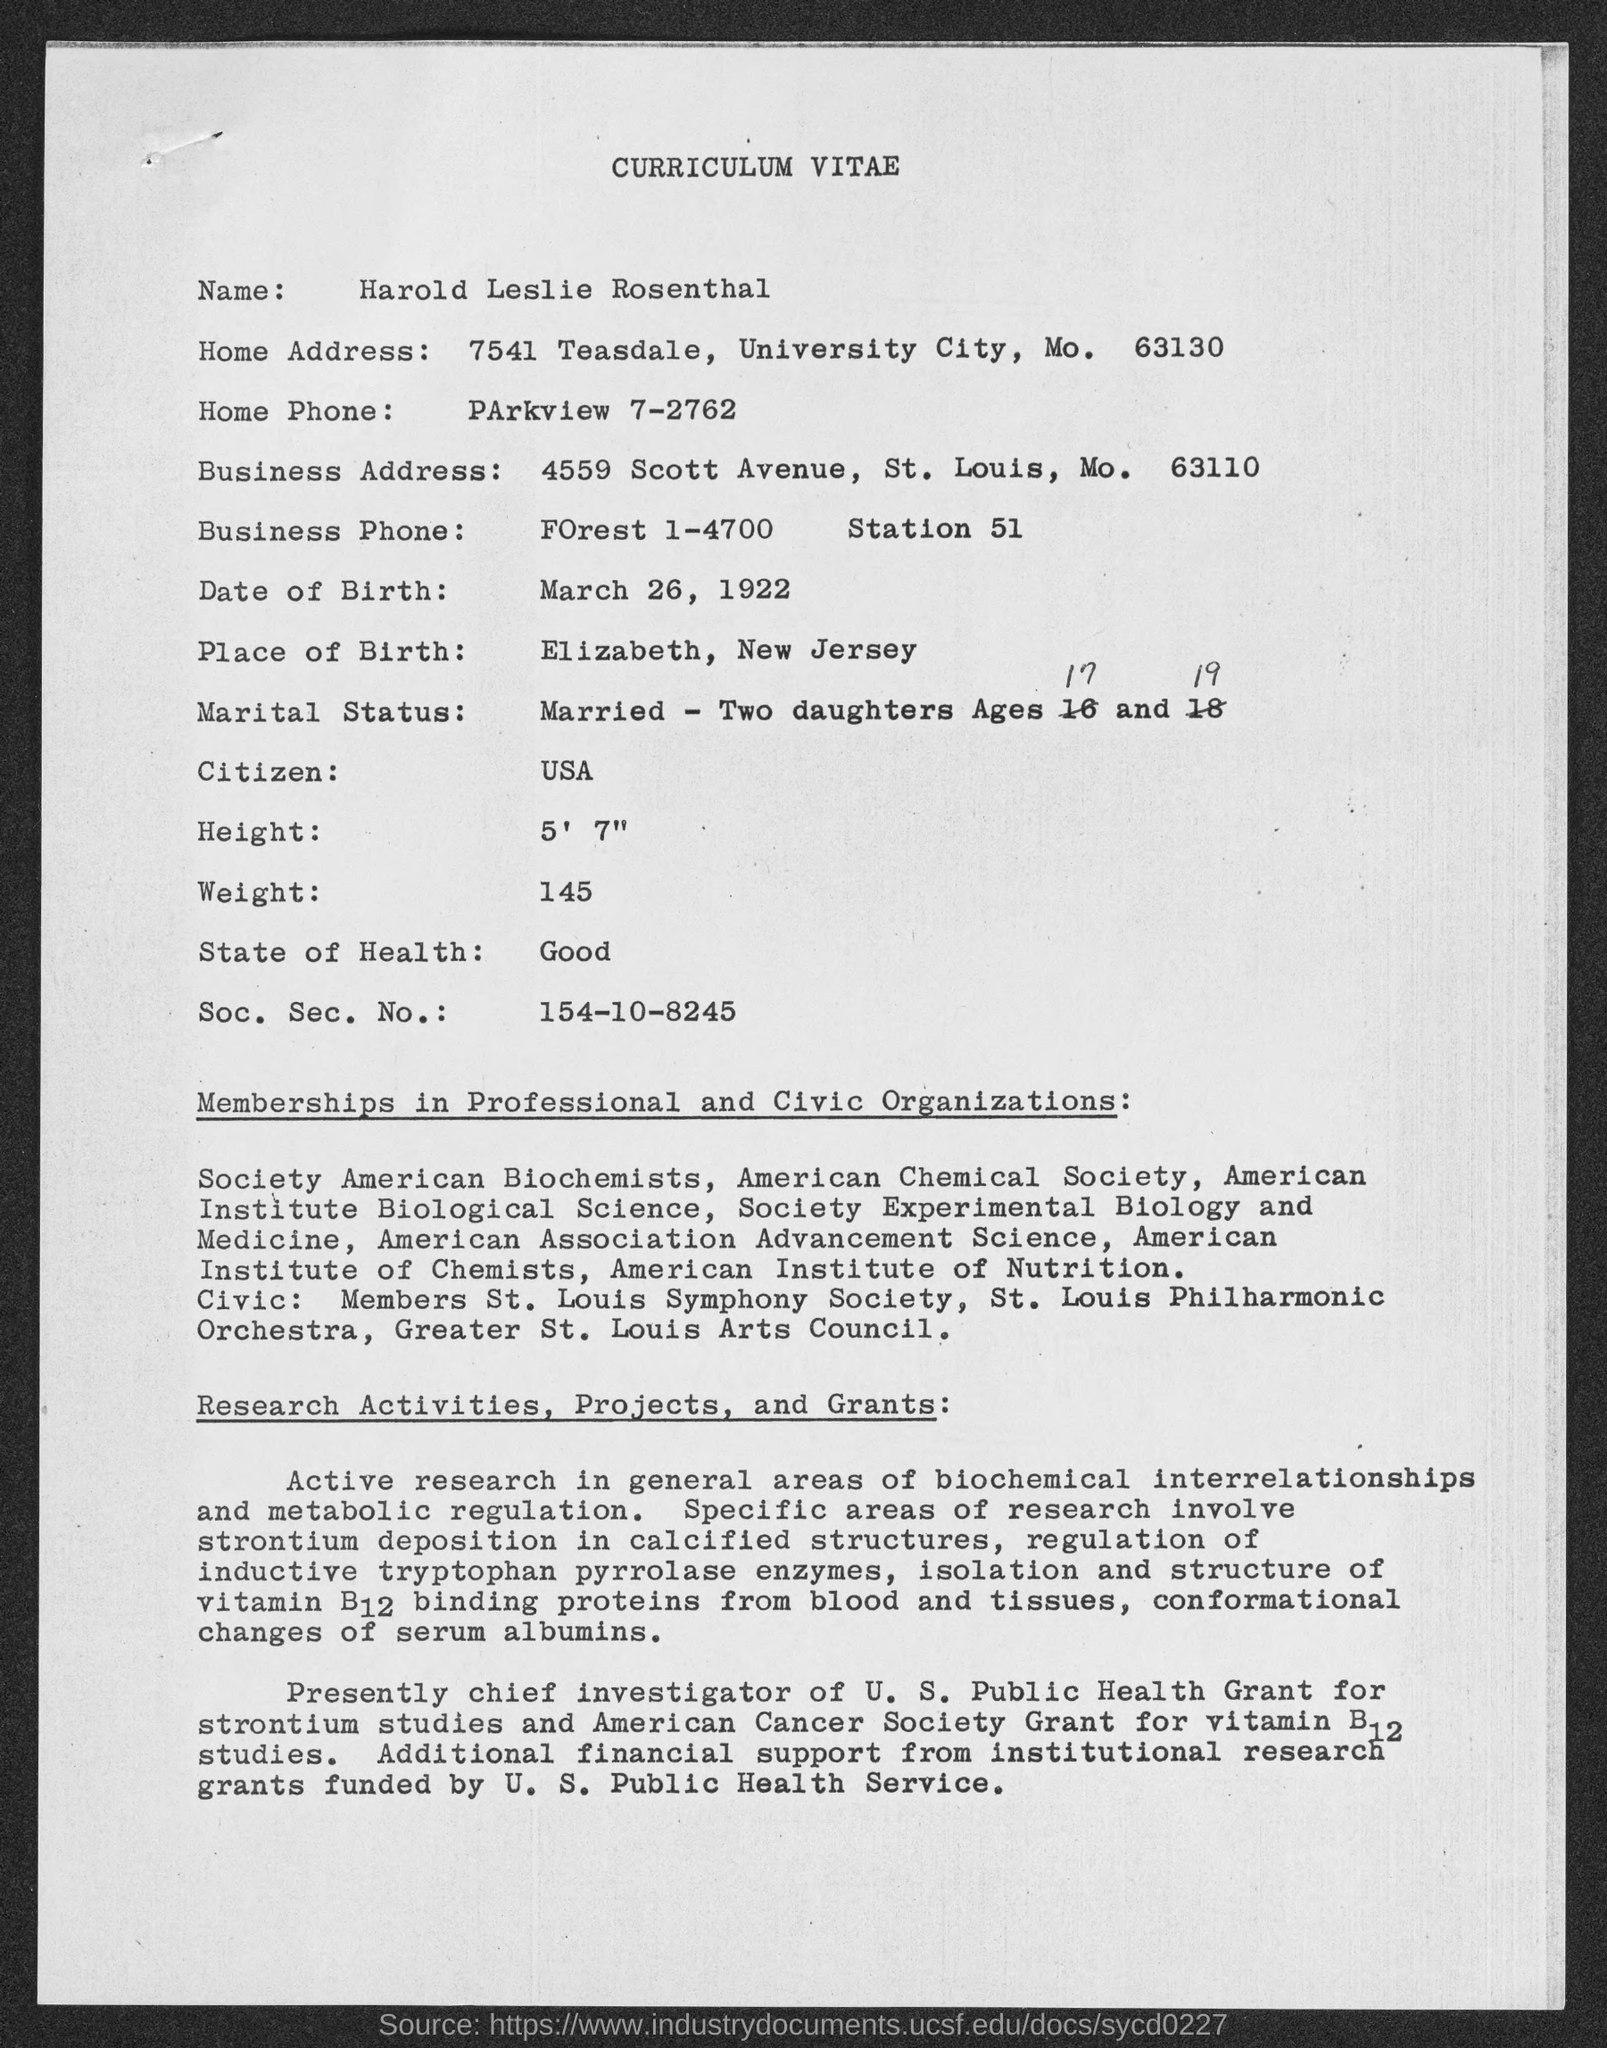Identify some key points in this picture. On March 26, 1922, the person's date of birth was given. This is a curriculum vitae, a type of documentation that provides information about an individual's education, work experience, and other relevant qualifications. The Social Security Number is 154-10-8245. Harold Leslie Rosenthal is the name given to someone. The home phone number given is Parkview 7-2762. 